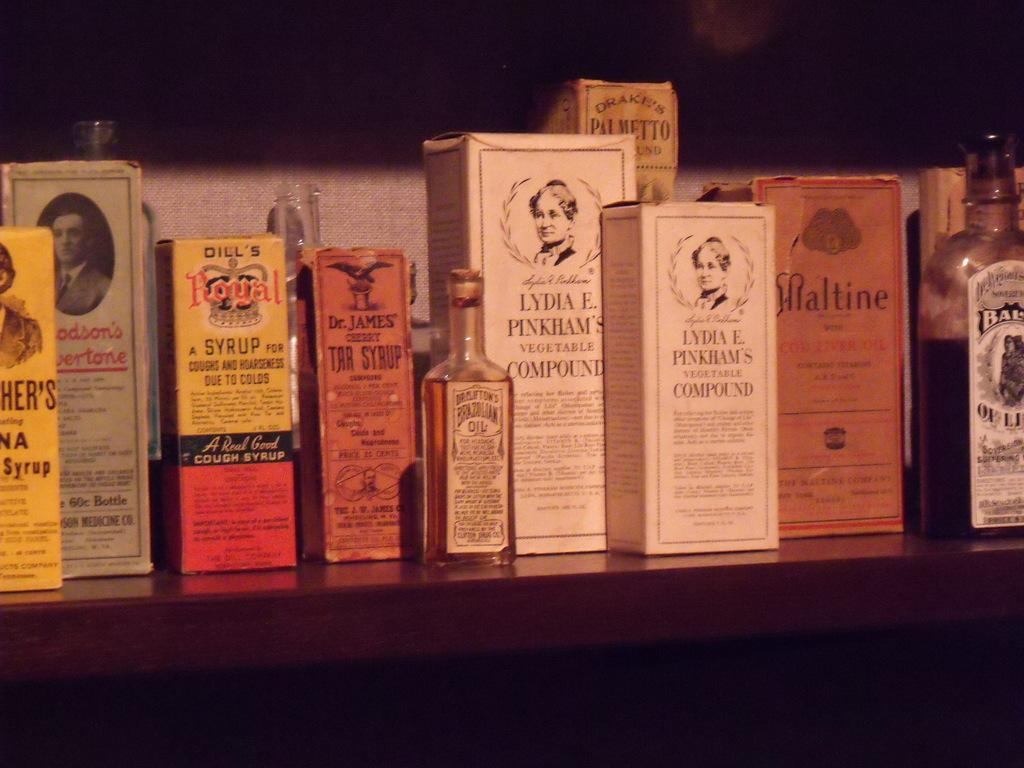<image>
Provide a brief description of the given image. Lydia E. Pinkham's Vegetable Compound in between some other boxes of condiments. 